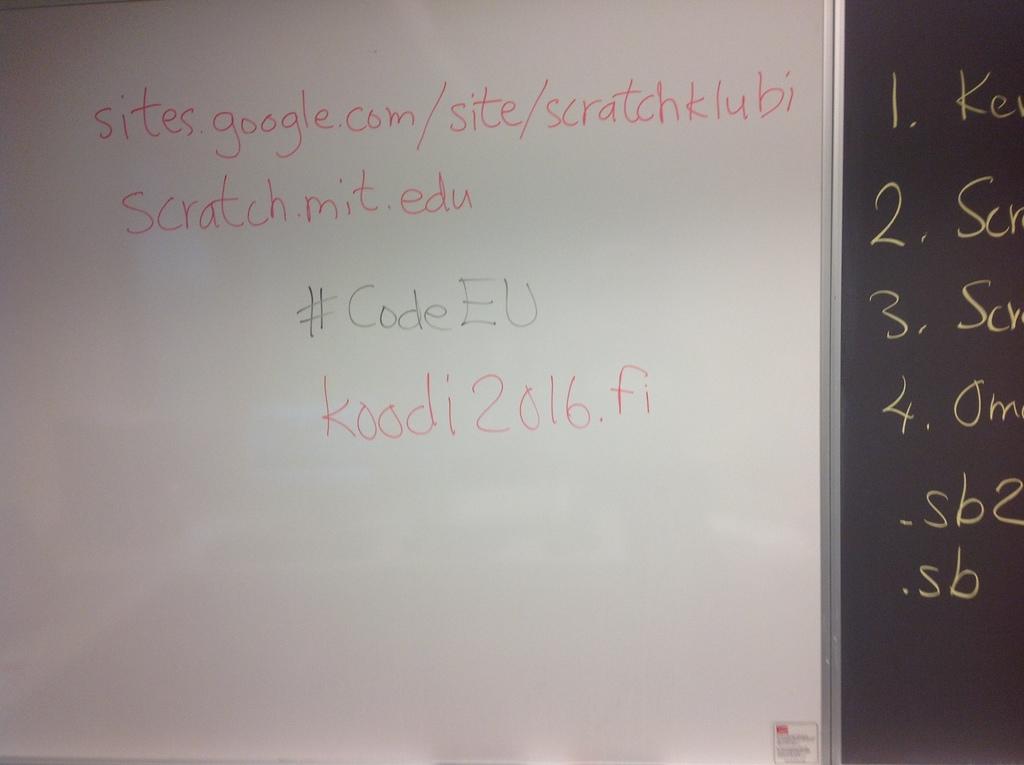What year does it say?
Offer a very short reply. 2016. What website is written in red marker?
Offer a terse response. Sites.google.com/site/scratchklubi. 